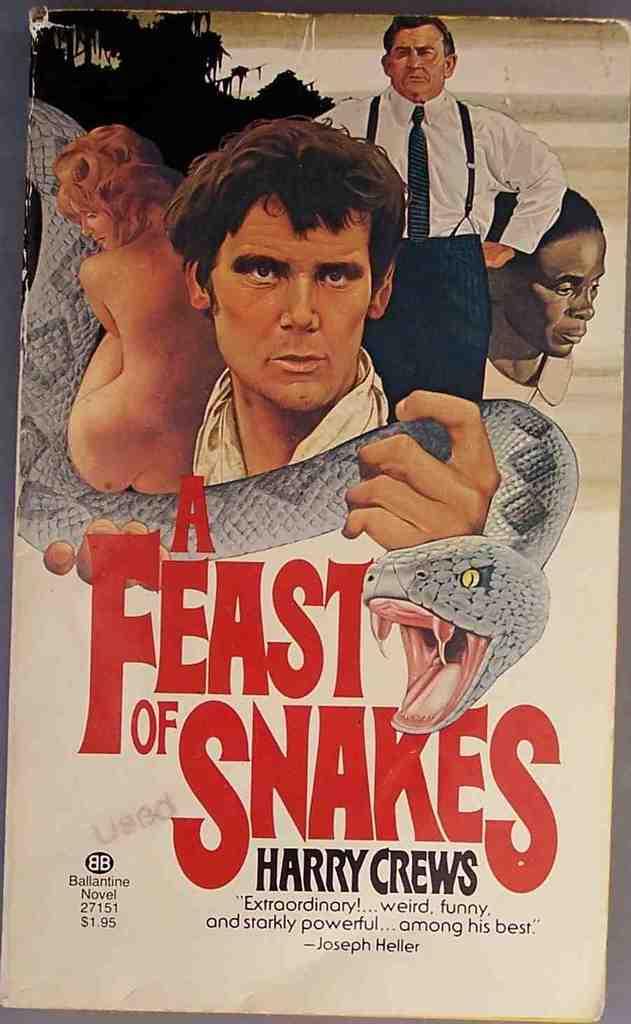What is the title of this book?
Your answer should be very brief. A feast of snakes. Who wrote the book?
Offer a terse response. Harry crews. 